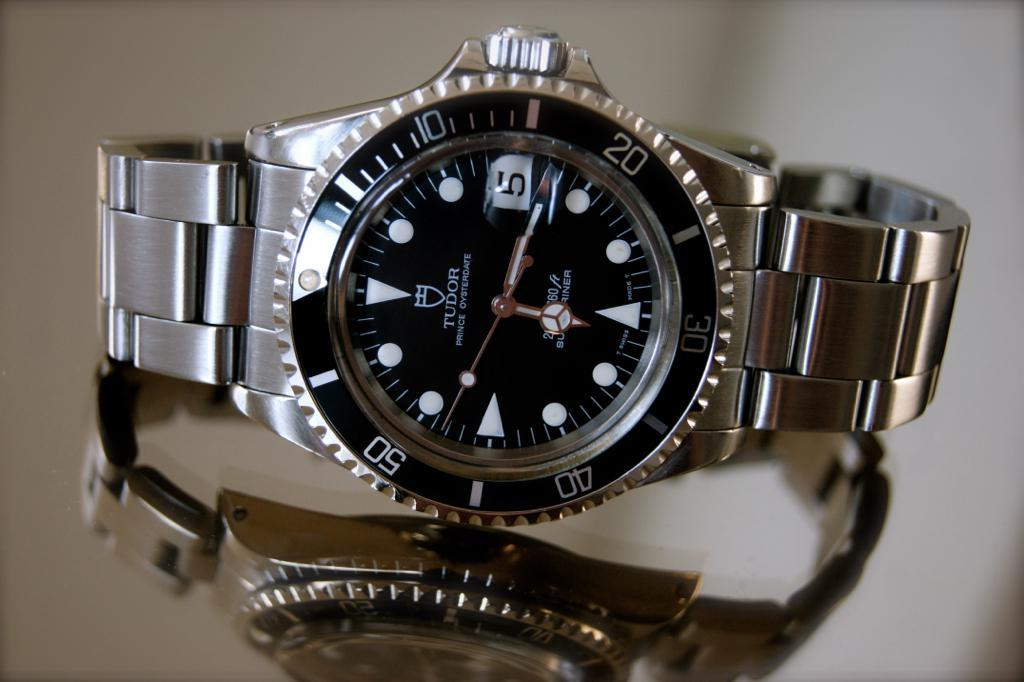Provide a one-sentence caption for the provided image. A silver watch says Tudor on the face. 